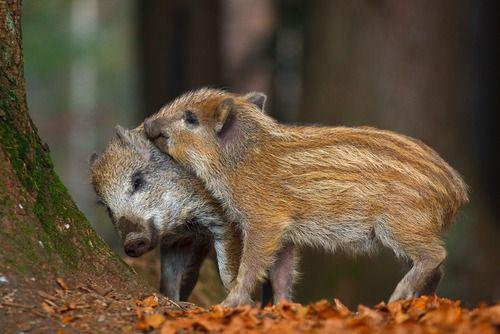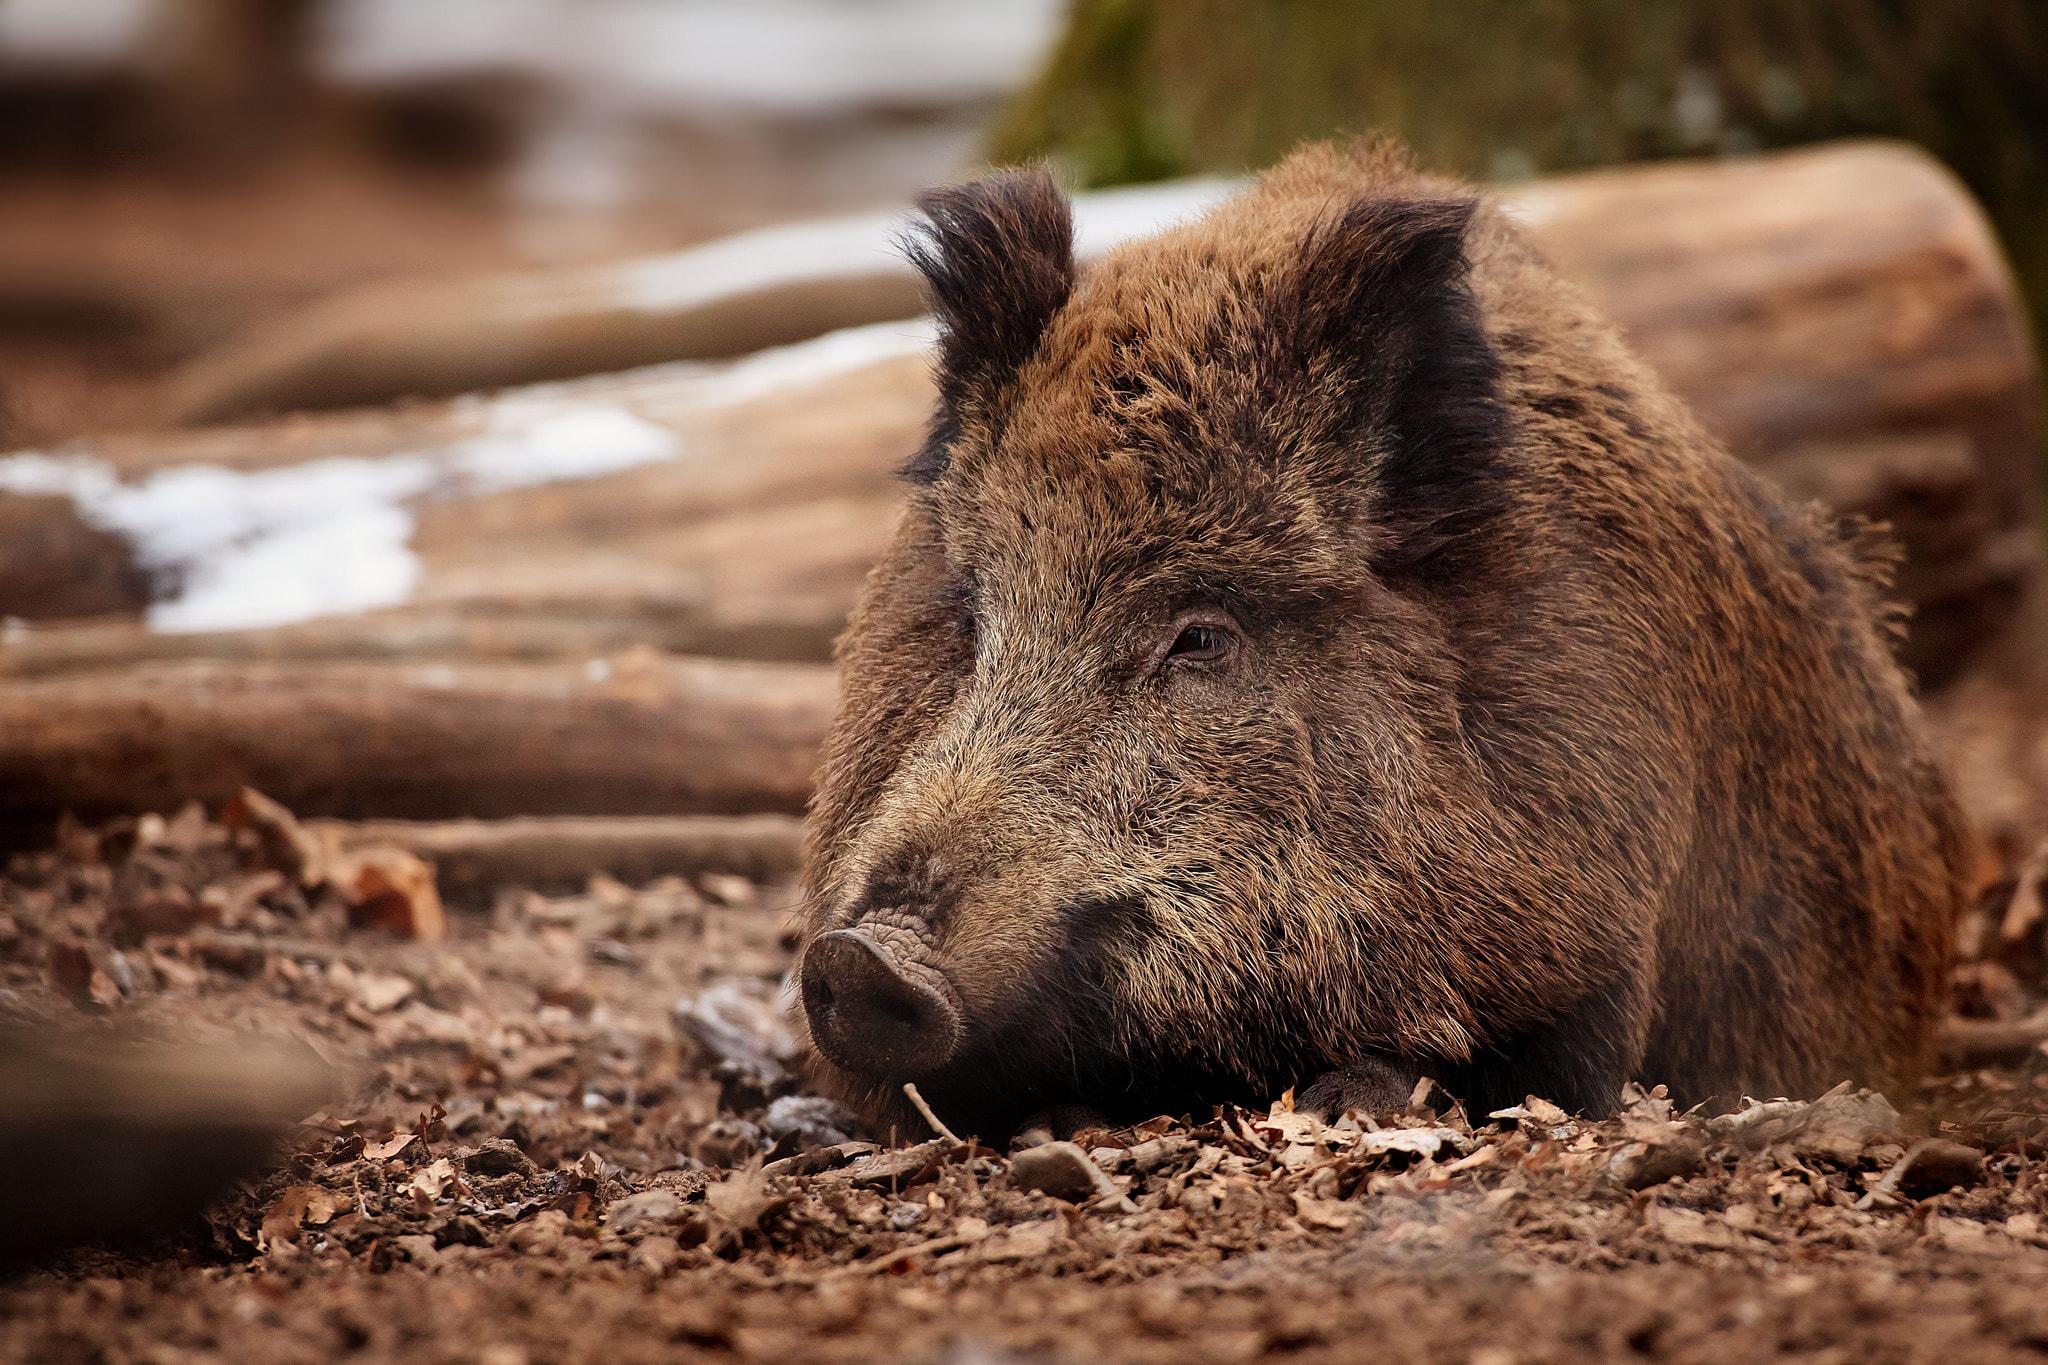The first image is the image on the left, the second image is the image on the right. Given the left and right images, does the statement "There are exactly three pigs." hold true? Answer yes or no. Yes. The first image is the image on the left, the second image is the image on the right. Evaluate the accuracy of this statement regarding the images: "There are three hogs in the pair of images.". Is it true? Answer yes or no. Yes. 